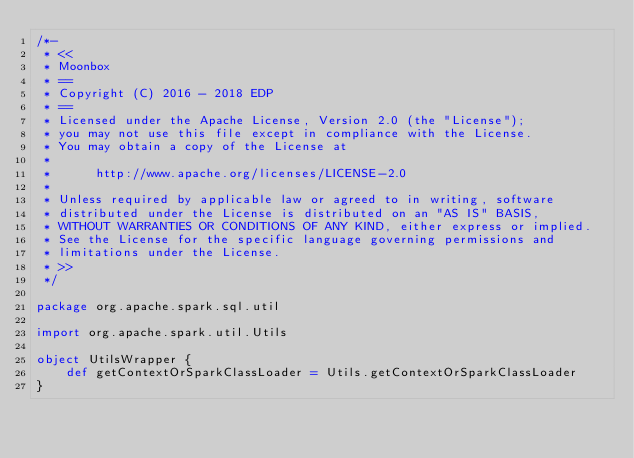<code> <loc_0><loc_0><loc_500><loc_500><_Scala_>/*-
 * <<
 * Moonbox
 * ==
 * Copyright (C) 2016 - 2018 EDP
 * ==
 * Licensed under the Apache License, Version 2.0 (the "License");
 * you may not use this file except in compliance with the License.
 * You may obtain a copy of the License at
 * 
 *      http://www.apache.org/licenses/LICENSE-2.0
 * 
 * Unless required by applicable law or agreed to in writing, software
 * distributed under the License is distributed on an "AS IS" BASIS,
 * WITHOUT WARRANTIES OR CONDITIONS OF ANY KIND, either express or implied.
 * See the License for the specific language governing permissions and
 * limitations under the License.
 * >>
 */

package org.apache.spark.sql.util

import org.apache.spark.util.Utils

object UtilsWrapper {
    def getContextOrSparkClassLoader = Utils.getContextOrSparkClassLoader
}
</code> 